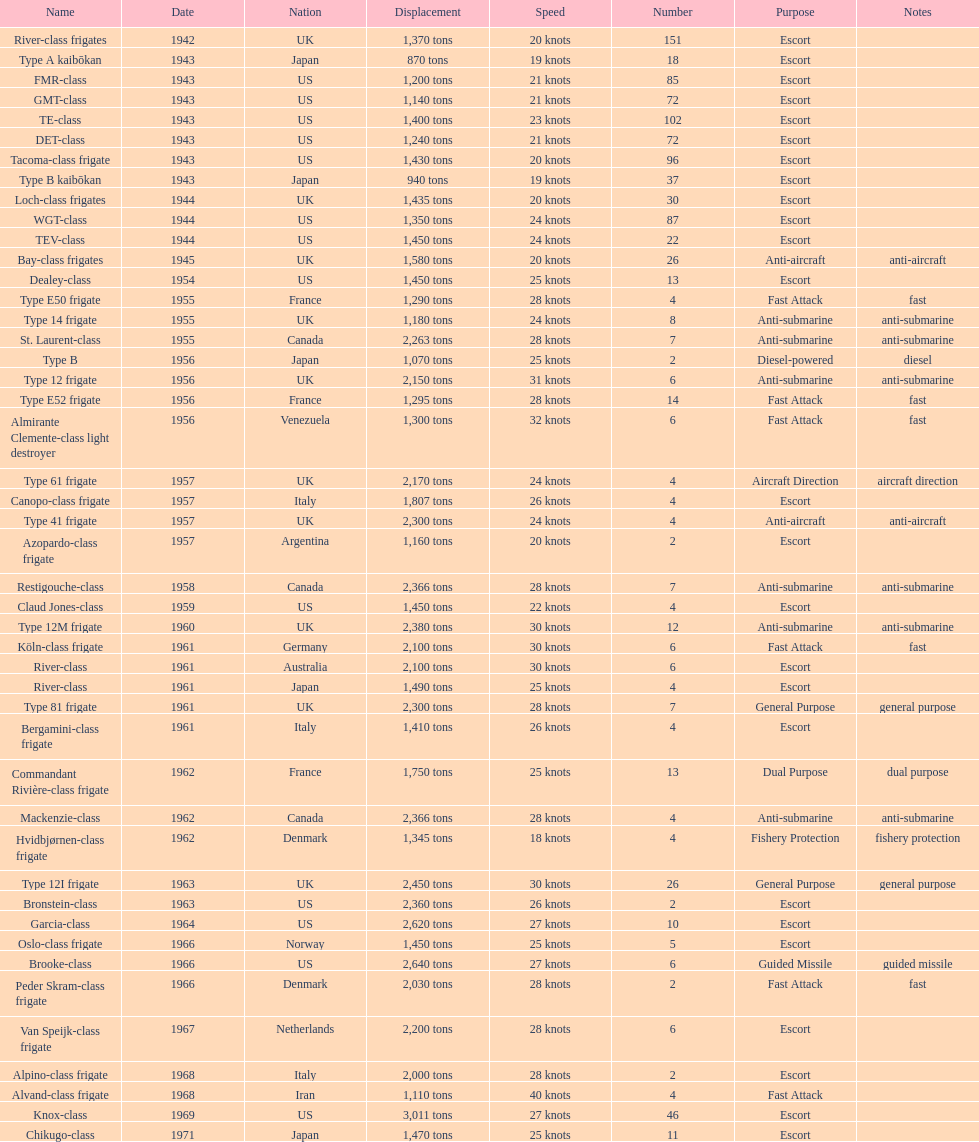How many tons does the te-class displace? 1,400 tons. 